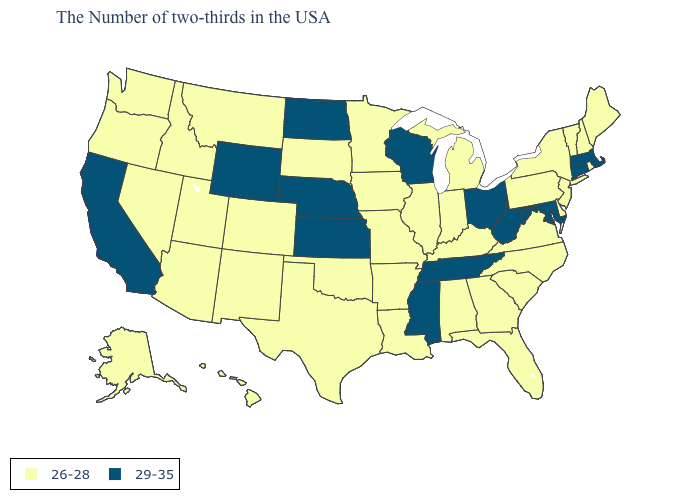Name the states that have a value in the range 29-35?
Be succinct. Massachusetts, Connecticut, Maryland, West Virginia, Ohio, Tennessee, Wisconsin, Mississippi, Kansas, Nebraska, North Dakota, Wyoming, California. What is the value of New Mexico?
Give a very brief answer. 26-28. What is the highest value in the USA?
Quick response, please. 29-35. What is the value of Idaho?
Answer briefly. 26-28. Does the map have missing data?
Keep it brief. No. Name the states that have a value in the range 29-35?
Concise answer only. Massachusetts, Connecticut, Maryland, West Virginia, Ohio, Tennessee, Wisconsin, Mississippi, Kansas, Nebraska, North Dakota, Wyoming, California. How many symbols are there in the legend?
Write a very short answer. 2. How many symbols are there in the legend?
Concise answer only. 2. What is the lowest value in the MidWest?
Quick response, please. 26-28. Which states have the lowest value in the USA?
Concise answer only. Maine, Rhode Island, New Hampshire, Vermont, New York, New Jersey, Delaware, Pennsylvania, Virginia, North Carolina, South Carolina, Florida, Georgia, Michigan, Kentucky, Indiana, Alabama, Illinois, Louisiana, Missouri, Arkansas, Minnesota, Iowa, Oklahoma, Texas, South Dakota, Colorado, New Mexico, Utah, Montana, Arizona, Idaho, Nevada, Washington, Oregon, Alaska, Hawaii. Does Ohio have the same value as North Dakota?
Write a very short answer. Yes. Name the states that have a value in the range 29-35?
Answer briefly. Massachusetts, Connecticut, Maryland, West Virginia, Ohio, Tennessee, Wisconsin, Mississippi, Kansas, Nebraska, North Dakota, Wyoming, California. What is the value of Nebraska?
Give a very brief answer. 29-35. Which states have the highest value in the USA?
Short answer required. Massachusetts, Connecticut, Maryland, West Virginia, Ohio, Tennessee, Wisconsin, Mississippi, Kansas, Nebraska, North Dakota, Wyoming, California. Does Indiana have the same value as North Dakota?
Keep it brief. No. 